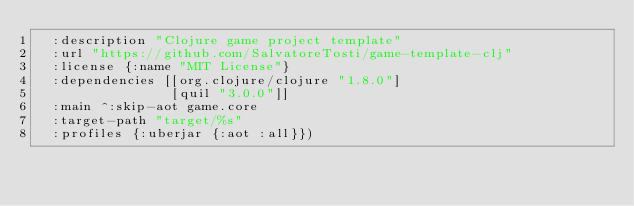Convert code to text. <code><loc_0><loc_0><loc_500><loc_500><_Clojure_>  :description "Clojure game project template"
  :url "https://github.com/SalvatoreTosti/game-template-clj"
  :license {:name "MIT License"}
  :dependencies [[org.clojure/clojure "1.8.0"]
                 [quil "3.0.0"]]
  :main ^:skip-aot game.core
  :target-path "target/%s"
  :profiles {:uberjar {:aot :all}})
</code> 